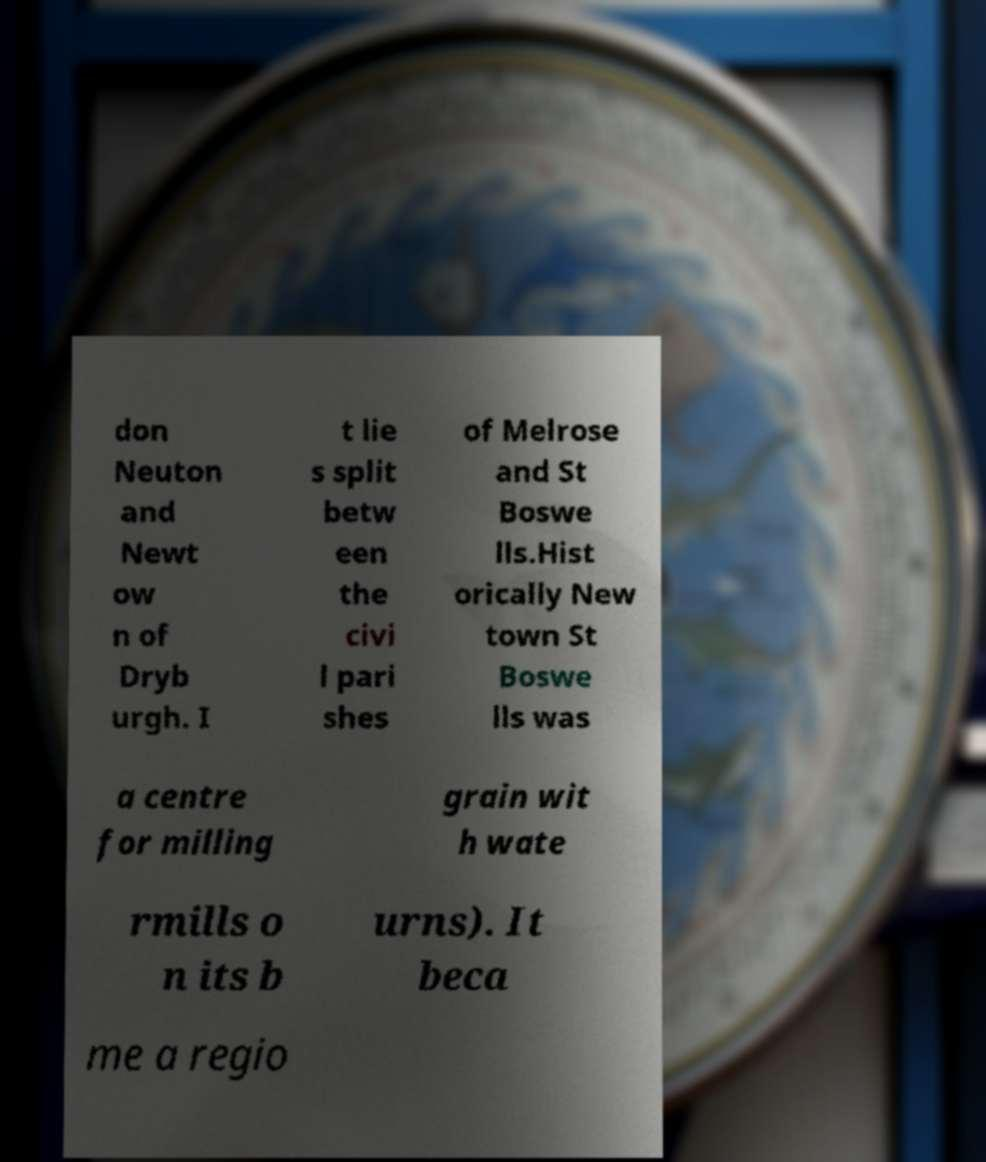Could you extract and type out the text from this image? don Neuton and Newt ow n of Dryb urgh. I t lie s split betw een the civi l pari shes of Melrose and St Boswe lls.Hist orically New town St Boswe lls was a centre for milling grain wit h wate rmills o n its b urns). It beca me a regio 